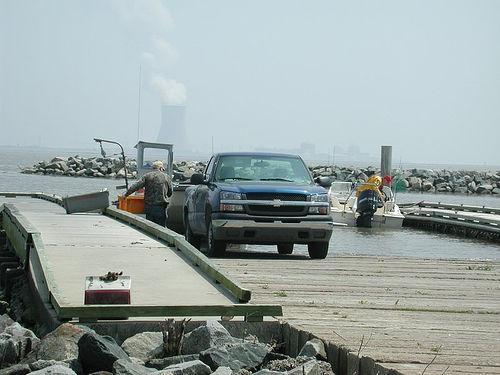What is the red and white box on the left used for? Please explain your reasoning. keeping cool. It is a cooler that keeps food chilly. 